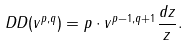<formula> <loc_0><loc_0><loc_500><loc_500>\ D D ( v ^ { p , q } ) = p \cdot v ^ { p - 1 , q + 1 } \frac { d z } { z } .</formula> 